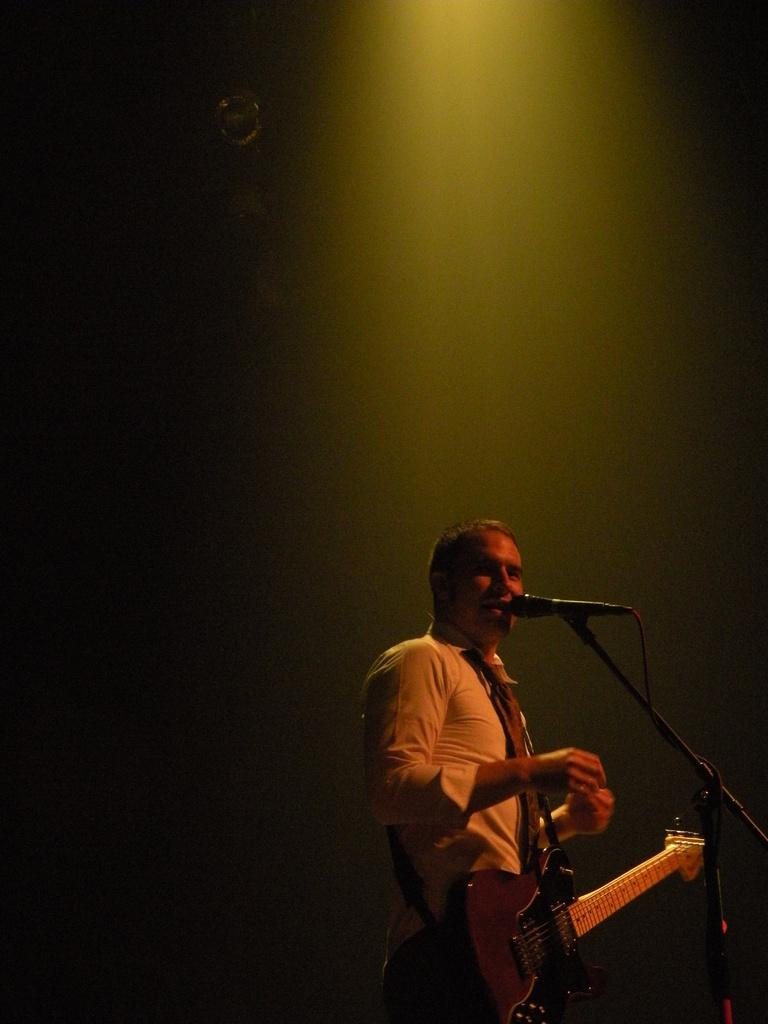Who is the main subject in the image? There is a man in the image. Where is the man located in the image? The man is standing on a stage. What is the man holding in the image? The man is holding a guitar. What object is present for amplifying the man's voice in the image? There is a microphone in the image. What is the man doing in the image? The man is singing a song. Can you see any agreements being signed on the seashore in the image? There is no seashore or agreement visible in the image; it features a man standing on a stage, holding a guitar, and singing into a microphone. 